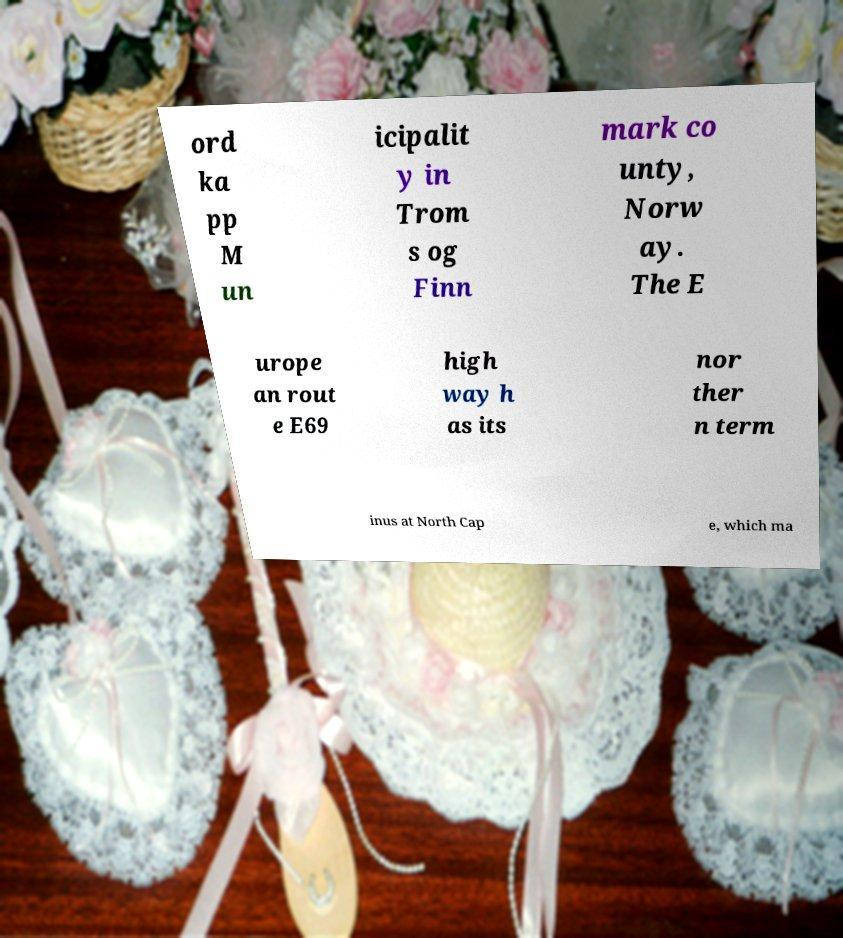There's text embedded in this image that I need extracted. Can you transcribe it verbatim? ord ka pp M un icipalit y in Trom s og Finn mark co unty, Norw ay. The E urope an rout e E69 high way h as its nor ther n term inus at North Cap e, which ma 